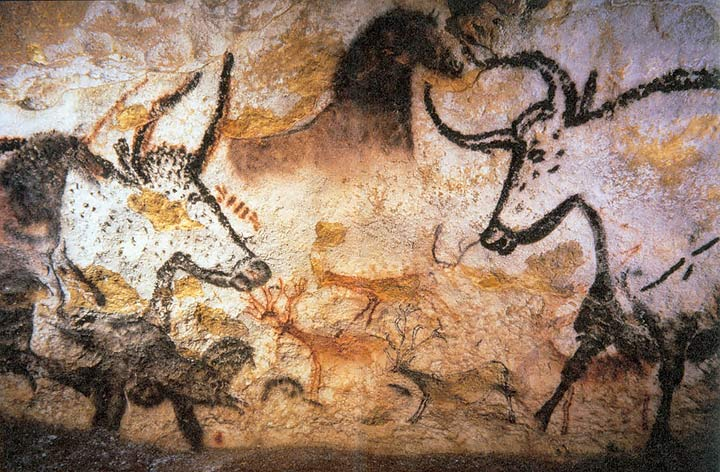How has the preservation of these cave paintings been managed? The preservation of the Lascaux Cave paintings has been challenging. The cave was closed to the public in 1963 to prevent damage from light exposure and changes in microclimate caused by visitors, which led to the growth of mold and lichens. Since then, strict climate control measures and limited access are maintained. Replicas and virtual tours have been created to allow the public to appreciate these artworks without endangering their condition. 